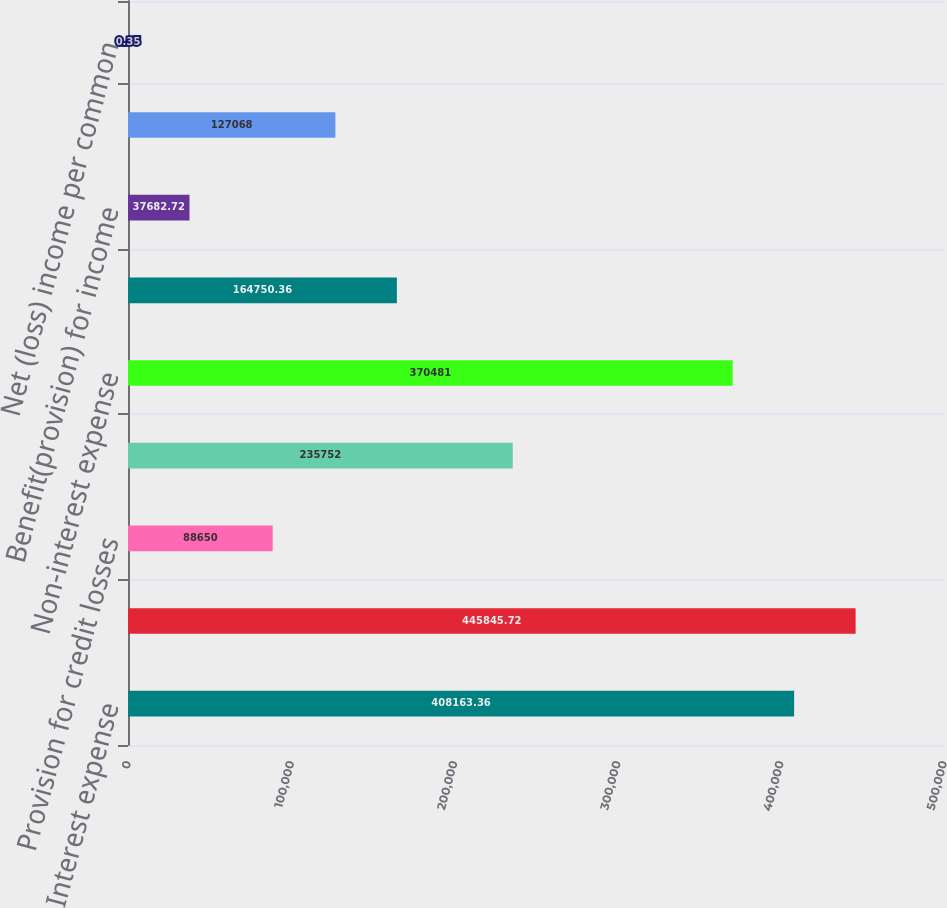<chart> <loc_0><loc_0><loc_500><loc_500><bar_chart><fcel>Interest expense<fcel>Net interest income<fcel>Provision for credit losses<fcel>Non-interest income<fcel>Non-interest expense<fcel>(Loss) income before income<fcel>Benefit(provision) for income<fcel>Net (loss)income<fcel>Net (loss) income per common<nl><fcel>408163<fcel>445846<fcel>88650<fcel>235752<fcel>370481<fcel>164750<fcel>37682.7<fcel>127068<fcel>0.35<nl></chart> 